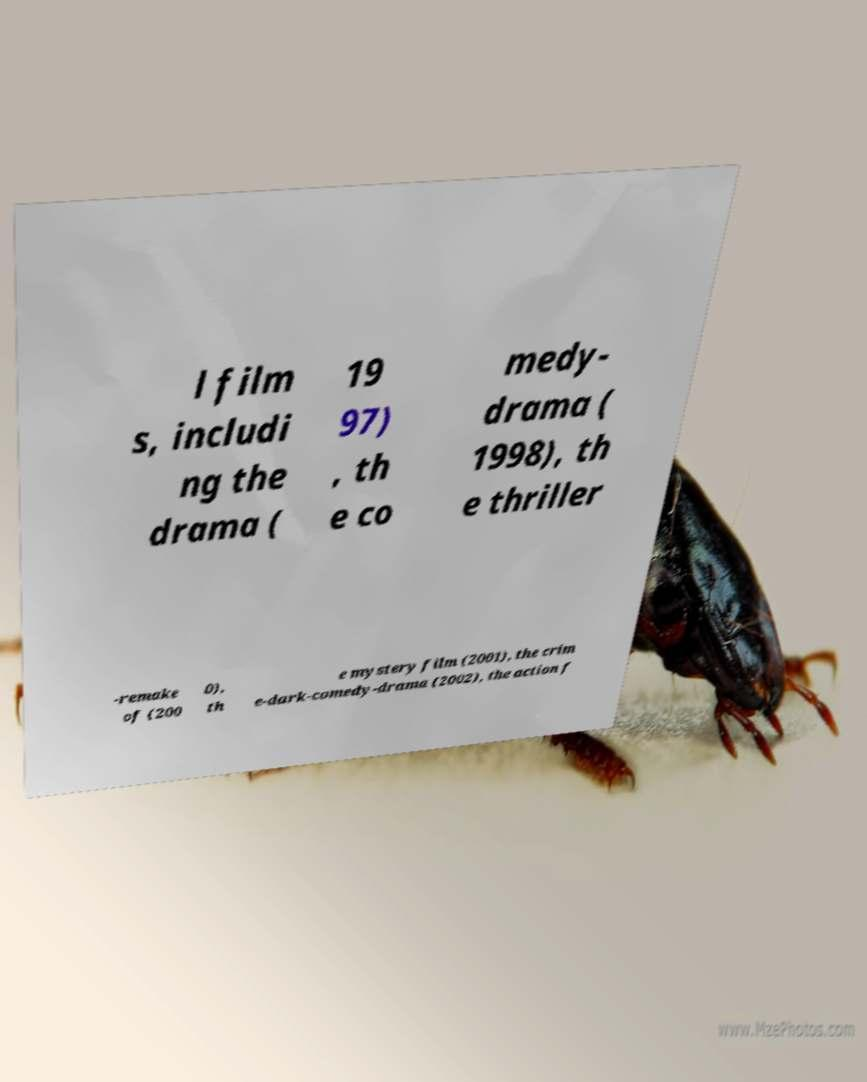Can you accurately transcribe the text from the provided image for me? l film s, includi ng the drama ( 19 97) , th e co medy- drama ( 1998), th e thriller -remake of (200 0), th e mystery film (2001), the crim e-dark-comedy-drama (2002), the action f 